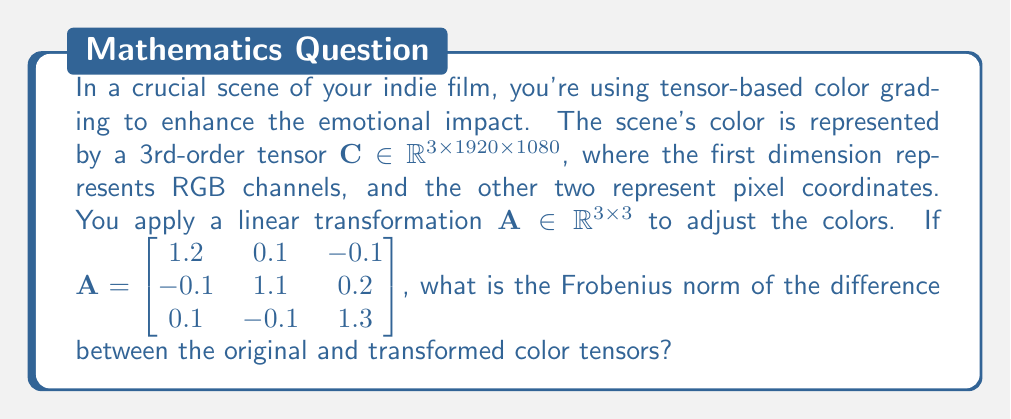Give your solution to this math problem. Let's approach this step-by-step:

1) The transformation $\mathbf{A}$ is applied to the RGB channels of each pixel. This operation can be expressed as a tensor contraction along the first dimension:

   $\mathbf{C'} = \mathbf{A} \cdot_1 \mathbf{C}$

   Where $\cdot_1$ denotes contraction along the first dimension.

2) The Frobenius norm of the difference between the original and transformed tensors is:

   $\|\mathbf{C'} - \mathbf{C}\|_F = \sqrt{\sum_{i,j,k} (C'_{ijk} - C_{ijk})^2}$

3) We can expand this using the linearity of the transformation:

   $\|\mathbf{C'} - \mathbf{C}\|_F = \|(\mathbf{A} - \mathbf{I}) \cdot_1 \mathbf{C}\|_F$

   Where $\mathbf{I}$ is the 3x3 identity matrix.

4) Let $\mathbf{B} = \mathbf{A} - \mathbf{I}$:

   $\mathbf{B} = \begin{bmatrix} 0.2 & 0.1 & -0.1 \\ -0.1 & 0.1 & 0.2 \\ 0.1 & -0.1 & 0.3 \end{bmatrix}$

5) The Frobenius norm of the transformed tensor can be related to the Frobenius norm of $\mathbf{B}$:

   $\|\mathbf{B} \cdot_1 \mathbf{C}\|_F^2 = \|\mathbf{B}\|_F^2 \|\mathbf{C}\|_F^2$

6) Calculate $\|\mathbf{B}\|_F^2$:

   $\|\mathbf{B}\|_F^2 = 0.2^2 + 0.1^2 + (-0.1)^2 + (-0.1)^2 + 0.1^2 + 0.2^2 + 0.1^2 + (-0.1)^2 + 0.3^2 = 0.26$

7) Therefore, the Frobenius norm of the difference is:

   $\|\mathbf{C'} - \mathbf{C}\|_F = \sqrt{0.26} \|\mathbf{C}\|_F \approx 0.51 \|\mathbf{C}\|_F$

The final result is expressed in terms of $\|\mathbf{C}\|_F$, as we don't have specific values for the original color tensor.
Answer: $0.51\|\mathbf{C}\|_F$ 